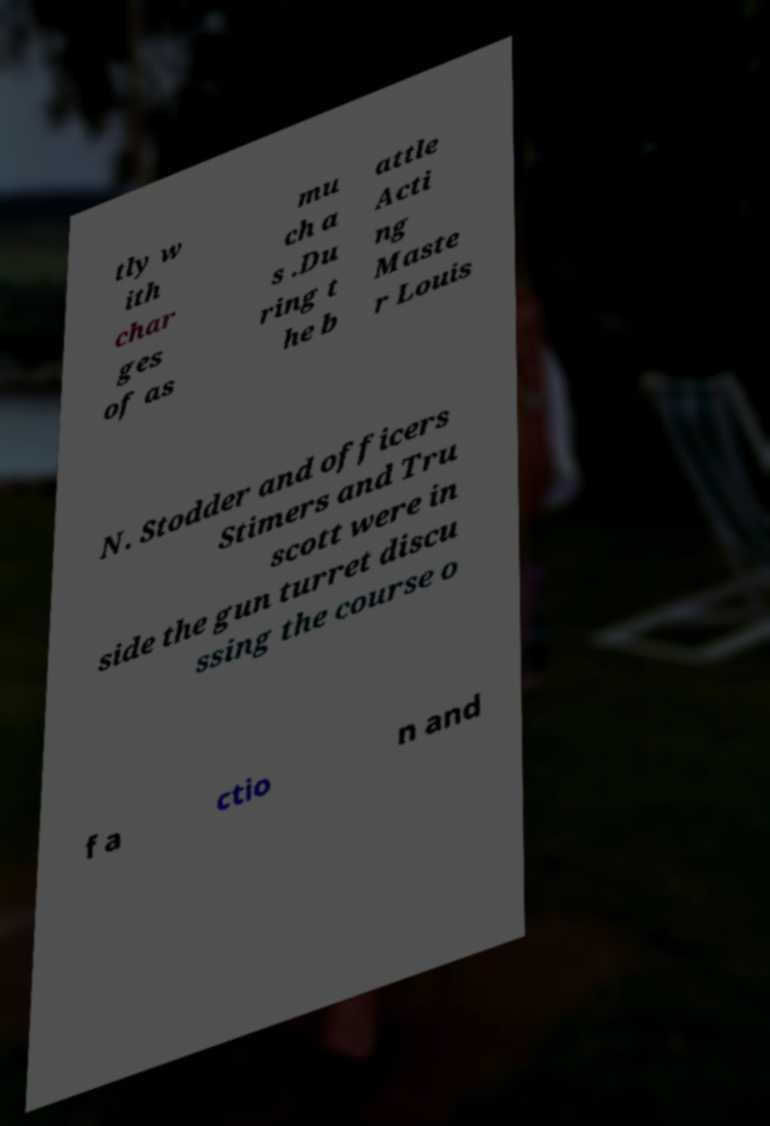I need the written content from this picture converted into text. Can you do that? tly w ith char ges of as mu ch a s .Du ring t he b attle Acti ng Maste r Louis N. Stodder and officers Stimers and Tru scott were in side the gun turret discu ssing the course o f a ctio n and 